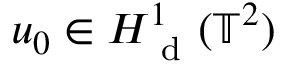Convert formula to latex. <formula><loc_0><loc_0><loc_500><loc_500>u _ { 0 } \in H _ { d } ^ { 1 } ( \mathbb { T } ^ { 2 } )</formula> 